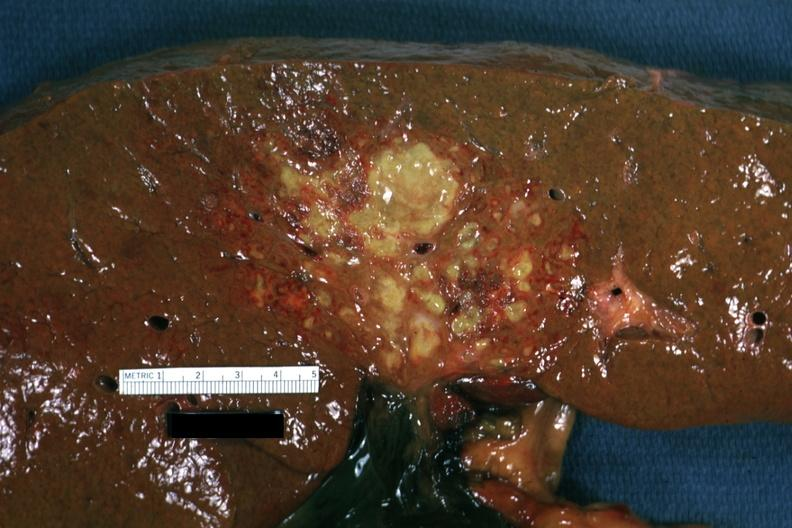s hepatobiliary present?
Answer the question using a single word or phrase. Yes 